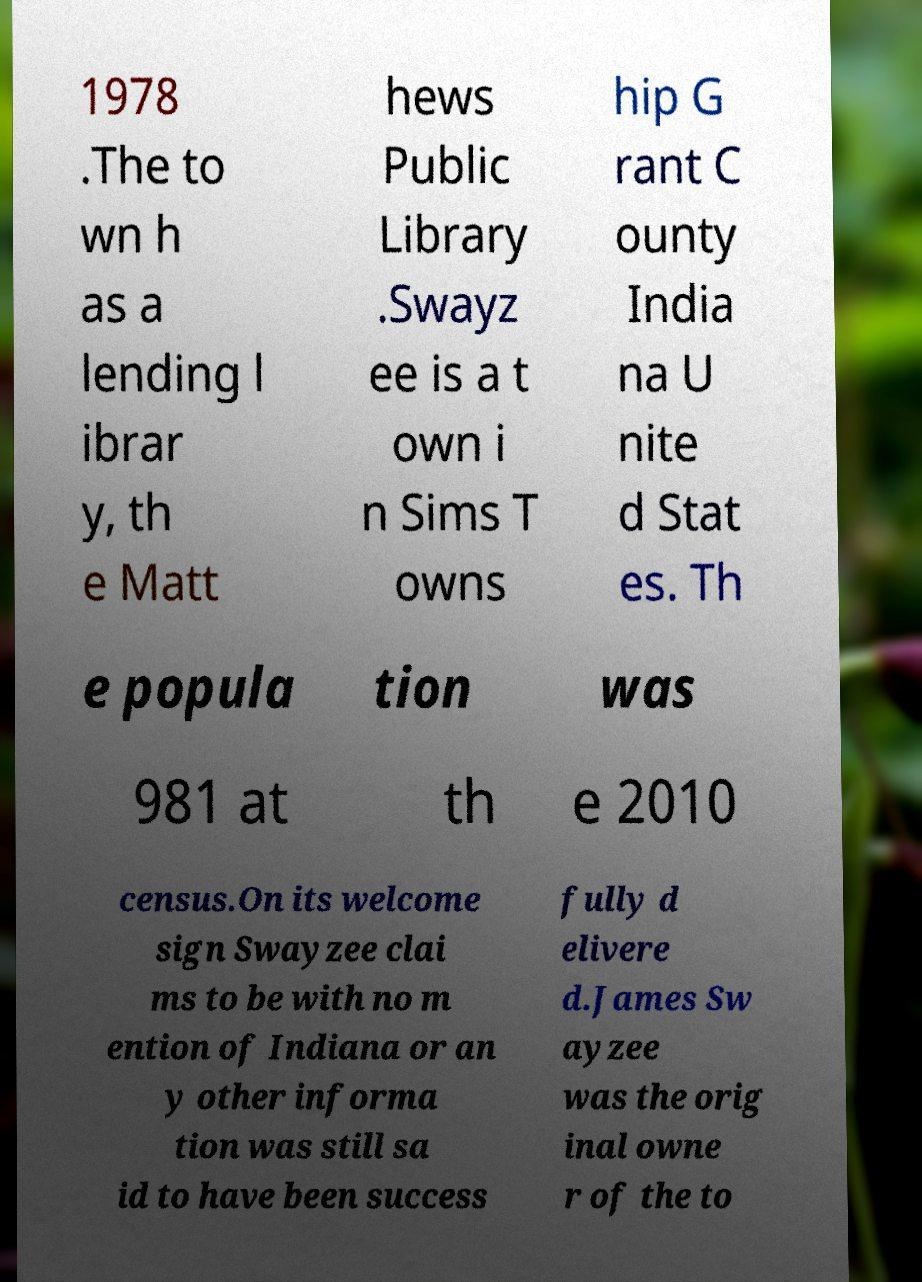Can you read and provide the text displayed in the image?This photo seems to have some interesting text. Can you extract and type it out for me? 1978 .The to wn h as a lending l ibrar y, th e Matt hews Public Library .Swayz ee is a t own i n Sims T owns hip G rant C ounty India na U nite d Stat es. Th e popula tion was 981 at th e 2010 census.On its welcome sign Swayzee clai ms to be with no m ention of Indiana or an y other informa tion was still sa id to have been success fully d elivere d.James Sw ayzee was the orig inal owne r of the to 